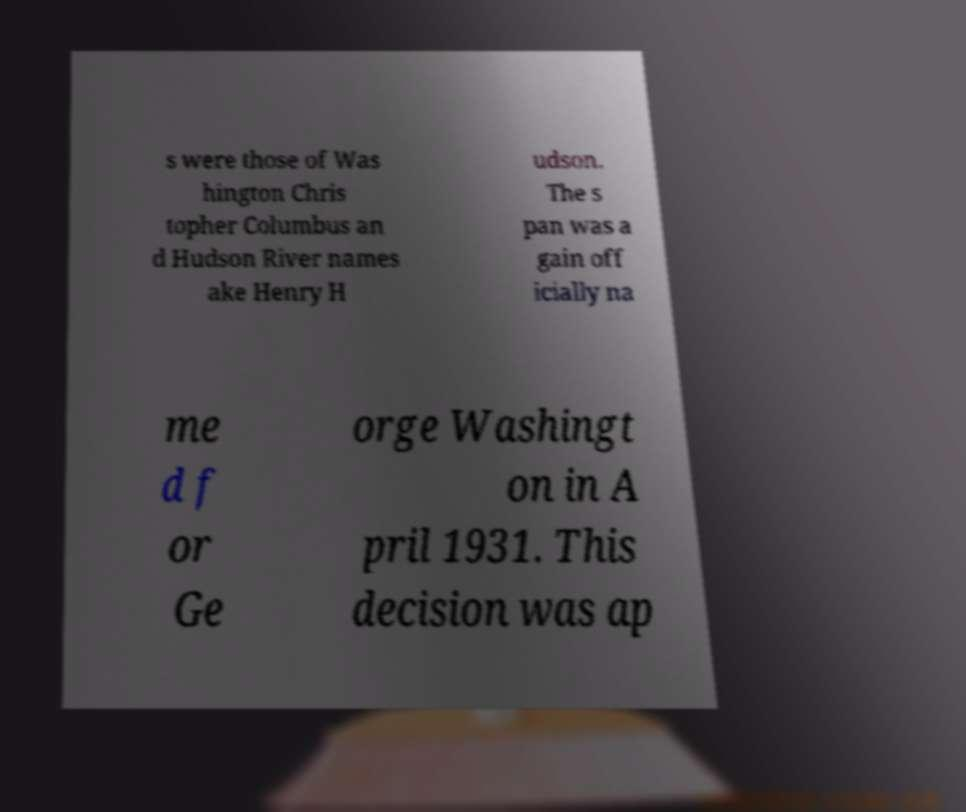Can you accurately transcribe the text from the provided image for me? s were those of Was hington Chris topher Columbus an d Hudson River names ake Henry H udson. The s pan was a gain off icially na me d f or Ge orge Washingt on in A pril 1931. This decision was ap 